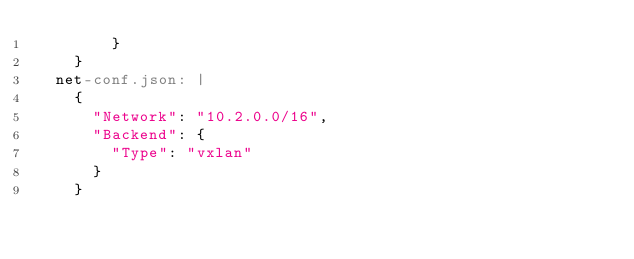Convert code to text. <code><loc_0><loc_0><loc_500><loc_500><_YAML_>        }
    }
  net-conf.json: |
    {
      "Network": "10.2.0.0/16",
      "Backend": {
        "Type": "vxlan"
      }
    }
</code> 